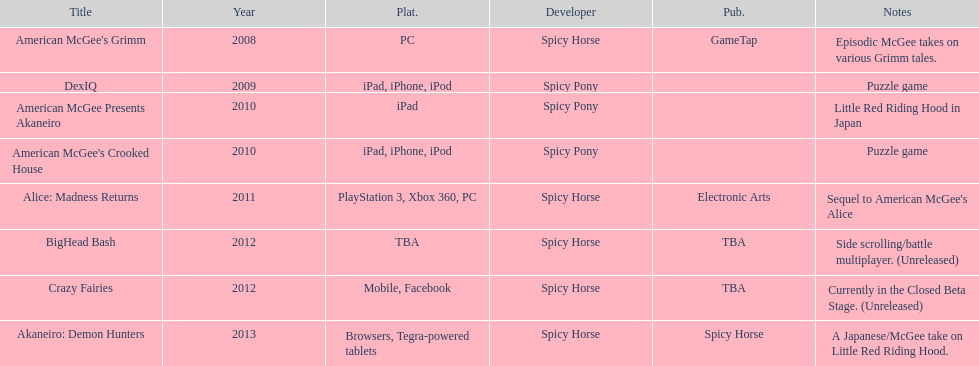Spicy pony released a total of three games; their game, "american mcgee's crooked house" was released on which platforms? Ipad, iphone, ipod. 